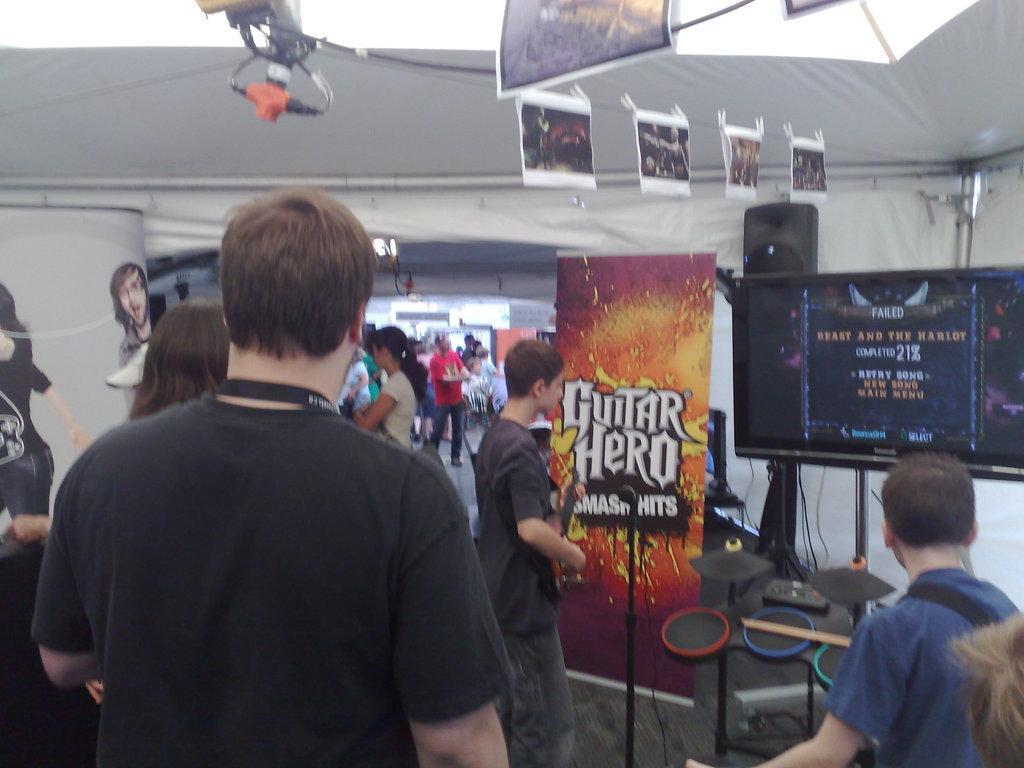Please provide a concise description of this image. In this image we can see a group of people standing. In that man is holding a guitar. On the right side we can see a mic with a stand, a television with some wires, a speaker, a banner with some text on it and a person playing a musical instrument holding the sticks. We can also see some photos hanged to a thread and some wires. On the left side we can see some stickers on a wall. 